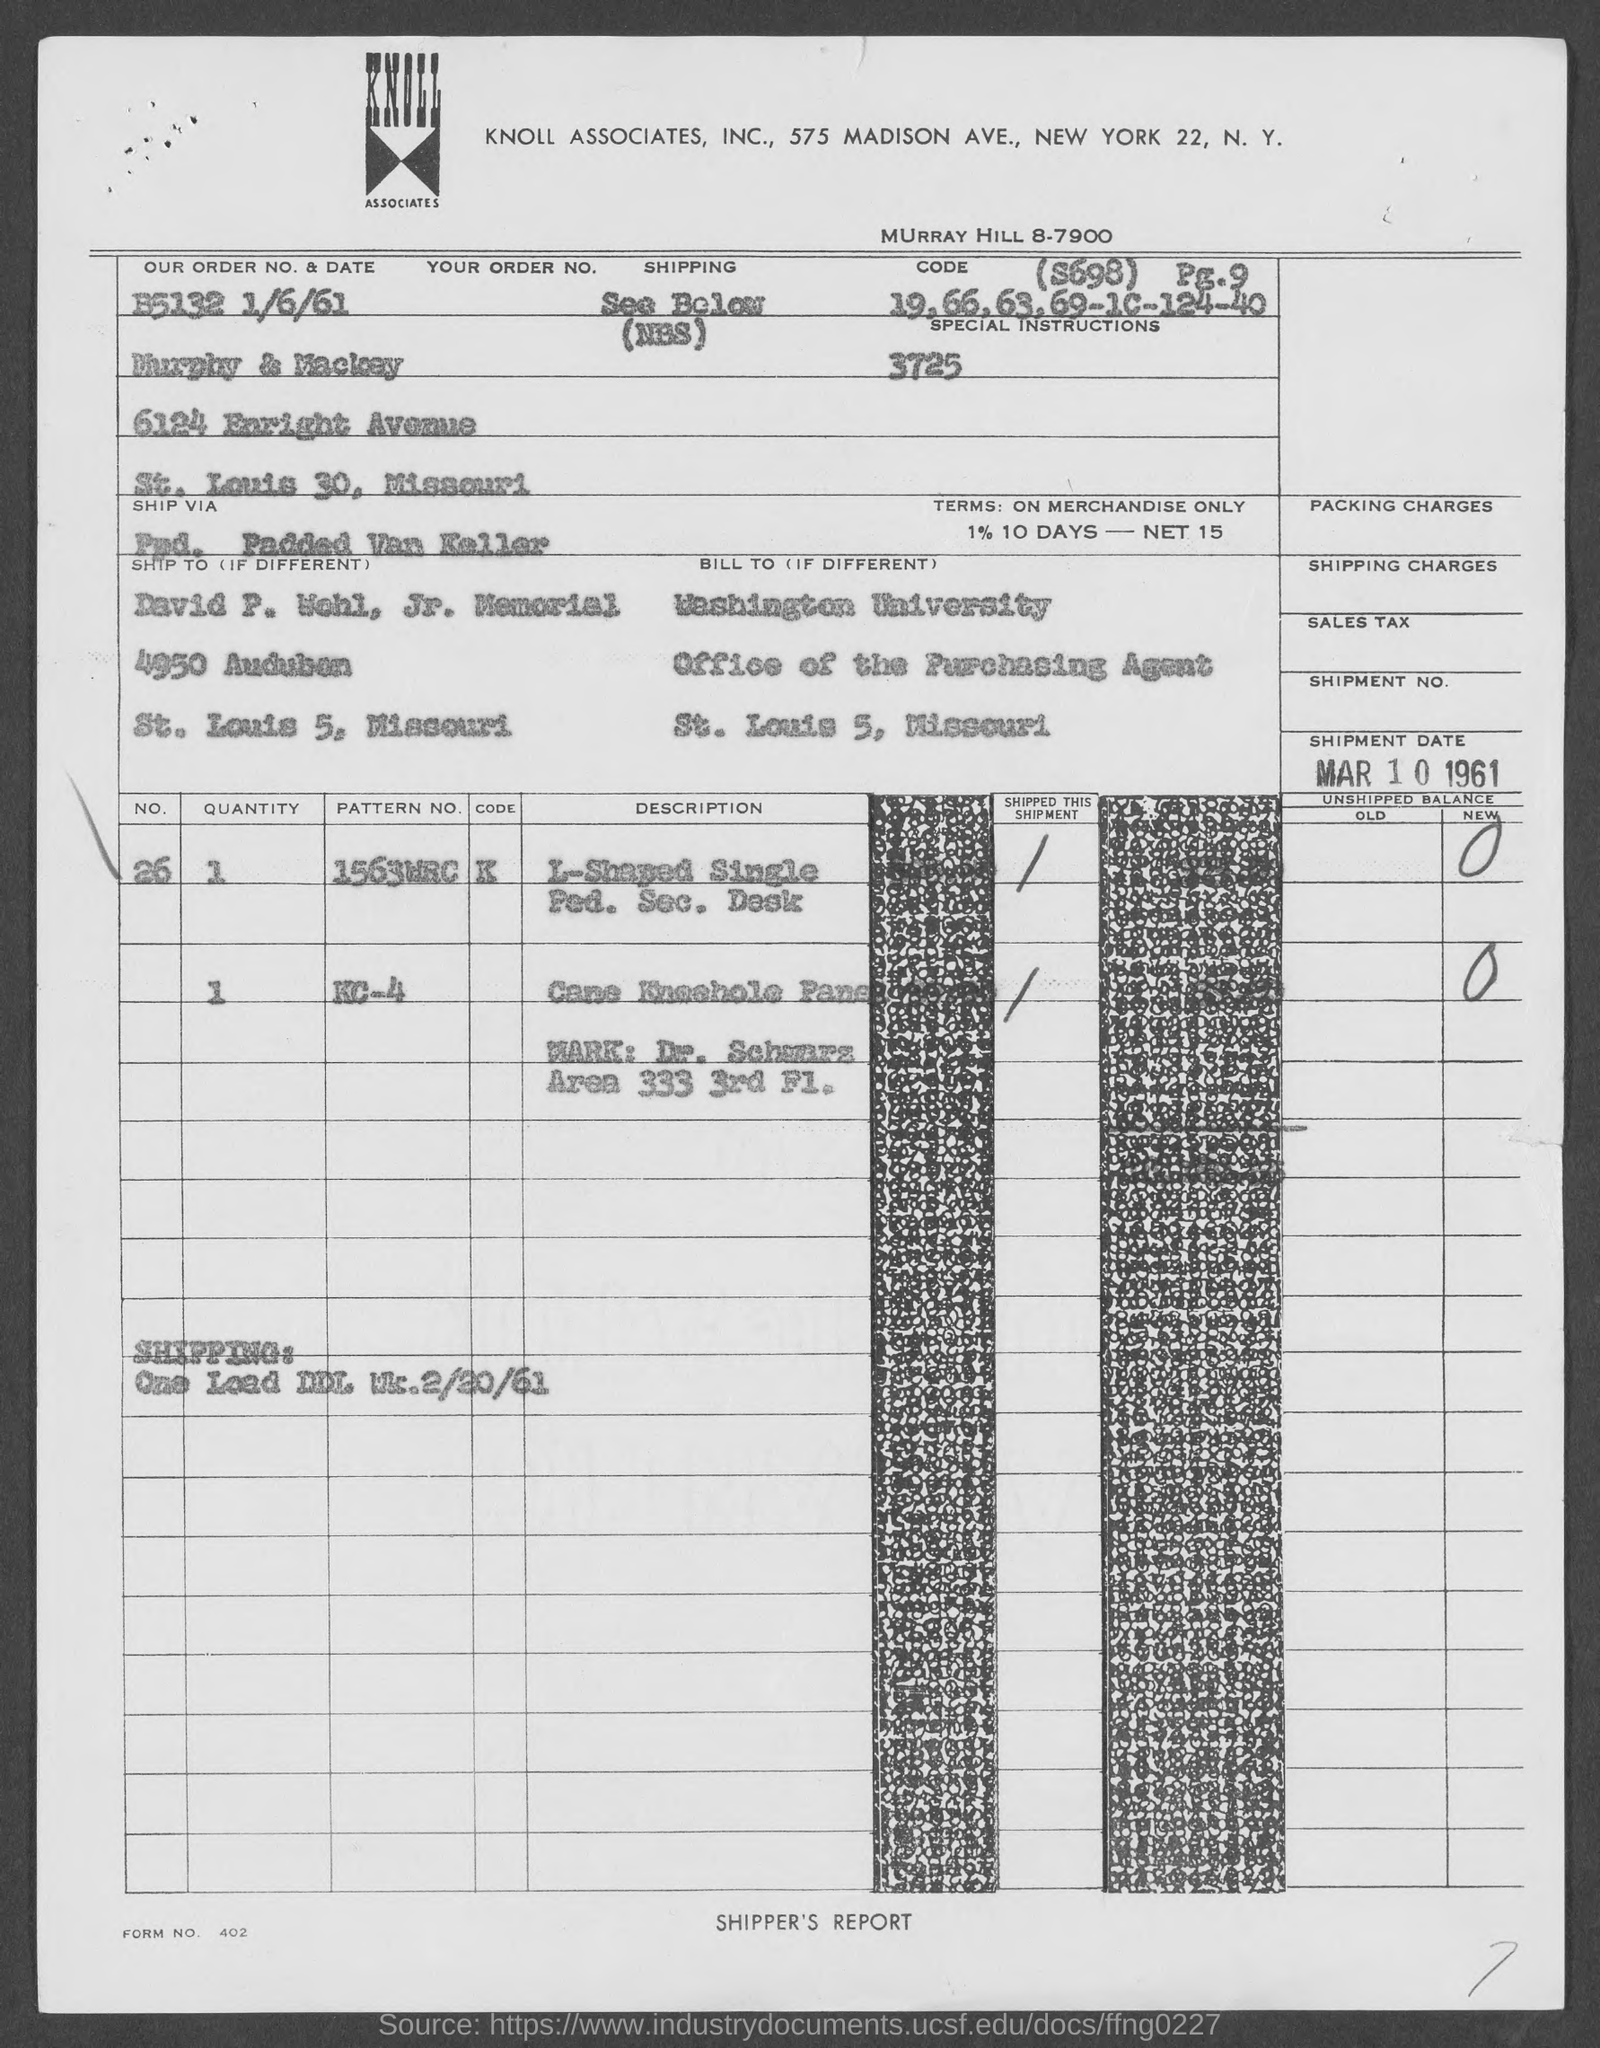What is the form no.?
Your answer should be compact. 402. In which county is washington university  located?
Your response must be concise. St. louis 5. In which state is david p. wohl, jr. memorial ?
Your answer should be compact. Missouri. What is the our order no.?
Offer a terse response. B5132. What is our date ?
Provide a succinct answer. 1/6/61. 